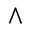<formula> <loc_0><loc_0><loc_500><loc_500>\wedge</formula> 